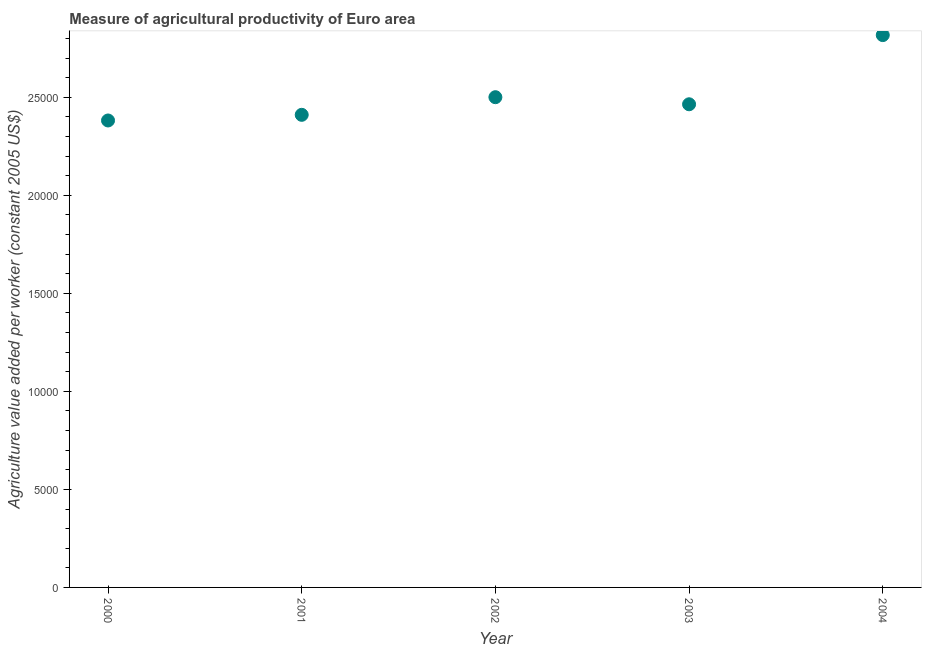What is the agriculture value added per worker in 2001?
Offer a very short reply. 2.41e+04. Across all years, what is the maximum agriculture value added per worker?
Provide a succinct answer. 2.82e+04. Across all years, what is the minimum agriculture value added per worker?
Make the answer very short. 2.38e+04. In which year was the agriculture value added per worker maximum?
Offer a very short reply. 2004. What is the sum of the agriculture value added per worker?
Give a very brief answer. 1.26e+05. What is the difference between the agriculture value added per worker in 2002 and 2003?
Provide a succinct answer. 361. What is the average agriculture value added per worker per year?
Ensure brevity in your answer.  2.51e+04. What is the median agriculture value added per worker?
Offer a terse response. 2.46e+04. In how many years, is the agriculture value added per worker greater than 10000 US$?
Provide a short and direct response. 5. What is the ratio of the agriculture value added per worker in 2001 to that in 2003?
Your answer should be compact. 0.98. Is the difference between the agriculture value added per worker in 2000 and 2002 greater than the difference between any two years?
Provide a short and direct response. No. What is the difference between the highest and the second highest agriculture value added per worker?
Provide a short and direct response. 3167.47. What is the difference between the highest and the lowest agriculture value added per worker?
Your response must be concise. 4355.04. In how many years, is the agriculture value added per worker greater than the average agriculture value added per worker taken over all years?
Provide a succinct answer. 1. How many dotlines are there?
Provide a short and direct response. 1. How many years are there in the graph?
Give a very brief answer. 5. Are the values on the major ticks of Y-axis written in scientific E-notation?
Provide a short and direct response. No. Does the graph contain any zero values?
Provide a short and direct response. No. Does the graph contain grids?
Provide a short and direct response. No. What is the title of the graph?
Your response must be concise. Measure of agricultural productivity of Euro area. What is the label or title of the Y-axis?
Make the answer very short. Agriculture value added per worker (constant 2005 US$). What is the Agriculture value added per worker (constant 2005 US$) in 2000?
Provide a short and direct response. 2.38e+04. What is the Agriculture value added per worker (constant 2005 US$) in 2001?
Give a very brief answer. 2.41e+04. What is the Agriculture value added per worker (constant 2005 US$) in 2002?
Make the answer very short. 2.50e+04. What is the Agriculture value added per worker (constant 2005 US$) in 2003?
Give a very brief answer. 2.46e+04. What is the Agriculture value added per worker (constant 2005 US$) in 2004?
Ensure brevity in your answer.  2.82e+04. What is the difference between the Agriculture value added per worker (constant 2005 US$) in 2000 and 2001?
Give a very brief answer. -288.27. What is the difference between the Agriculture value added per worker (constant 2005 US$) in 2000 and 2002?
Offer a terse response. -1187.57. What is the difference between the Agriculture value added per worker (constant 2005 US$) in 2000 and 2003?
Provide a succinct answer. -826.57. What is the difference between the Agriculture value added per worker (constant 2005 US$) in 2000 and 2004?
Keep it short and to the point. -4355.04. What is the difference between the Agriculture value added per worker (constant 2005 US$) in 2001 and 2002?
Give a very brief answer. -899.3. What is the difference between the Agriculture value added per worker (constant 2005 US$) in 2001 and 2003?
Your answer should be compact. -538.3. What is the difference between the Agriculture value added per worker (constant 2005 US$) in 2001 and 2004?
Your answer should be compact. -4066.77. What is the difference between the Agriculture value added per worker (constant 2005 US$) in 2002 and 2003?
Offer a terse response. 361. What is the difference between the Agriculture value added per worker (constant 2005 US$) in 2002 and 2004?
Provide a succinct answer. -3167.47. What is the difference between the Agriculture value added per worker (constant 2005 US$) in 2003 and 2004?
Offer a very short reply. -3528.47. What is the ratio of the Agriculture value added per worker (constant 2005 US$) in 2000 to that in 2002?
Your answer should be very brief. 0.95. What is the ratio of the Agriculture value added per worker (constant 2005 US$) in 2000 to that in 2004?
Offer a terse response. 0.84. What is the ratio of the Agriculture value added per worker (constant 2005 US$) in 2001 to that in 2004?
Your response must be concise. 0.86. What is the ratio of the Agriculture value added per worker (constant 2005 US$) in 2002 to that in 2004?
Your answer should be very brief. 0.89. What is the ratio of the Agriculture value added per worker (constant 2005 US$) in 2003 to that in 2004?
Make the answer very short. 0.88. 